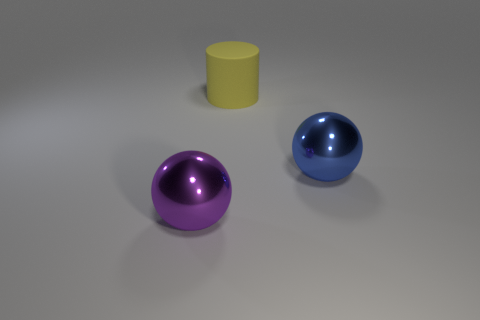Is there any other thing that is the same color as the large rubber thing?
Make the answer very short. No. What material is the large blue object to the right of the large purple ball that is left of the big ball right of the large purple sphere?
Offer a very short reply. Metal. Does the blue thing have the same shape as the big rubber thing?
Your answer should be very brief. No. Are there any other things that have the same material as the yellow cylinder?
Your answer should be compact. No. How many objects are both to the right of the large matte cylinder and on the left side of the big yellow rubber thing?
Ensure brevity in your answer.  0. What color is the shiny sphere that is in front of the big sphere that is right of the purple ball?
Ensure brevity in your answer.  Purple. Are there the same number of big objects that are to the right of the blue shiny sphere and big shiny objects?
Ensure brevity in your answer.  No. There is a metal ball to the right of the ball left of the large blue metallic ball; how many metallic things are left of it?
Your answer should be very brief. 1. What is the color of the shiny object on the right side of the big purple ball?
Offer a very short reply. Blue. What is the thing that is both behind the purple sphere and in front of the matte thing made of?
Offer a terse response. Metal. 